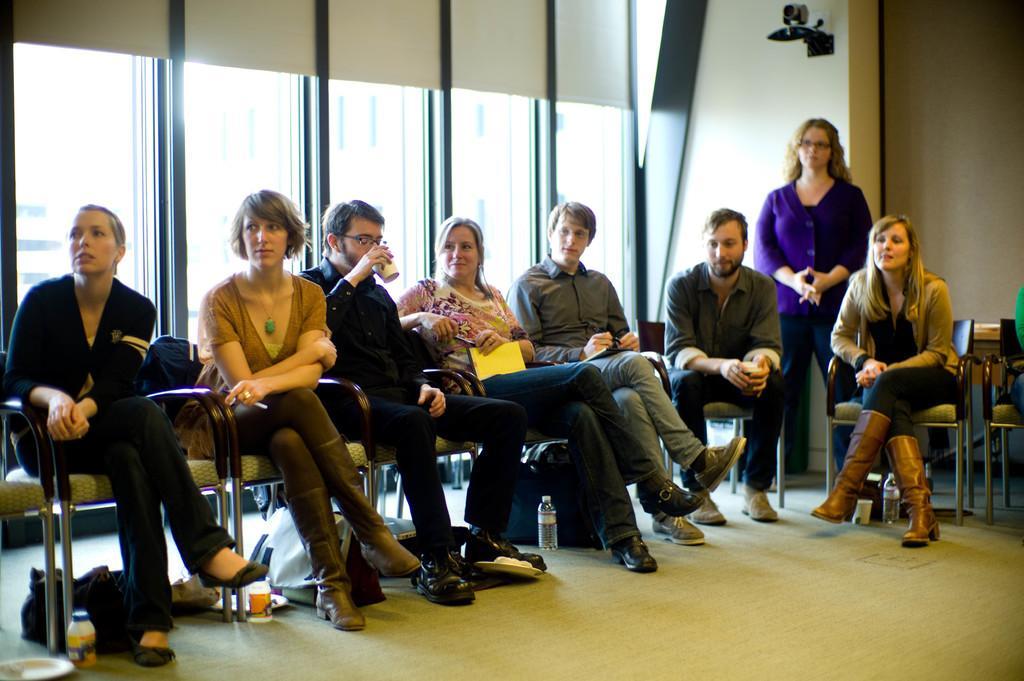In one or two sentences, can you explain what this image depicts? In this image I can see few people are sitting on the chairs and holding the cup and something. Back one person is standing. I can see the wall and glass windows. 